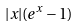Convert formula to latex. <formula><loc_0><loc_0><loc_500><loc_500>| x | ( e ^ { x } - 1 )</formula> 